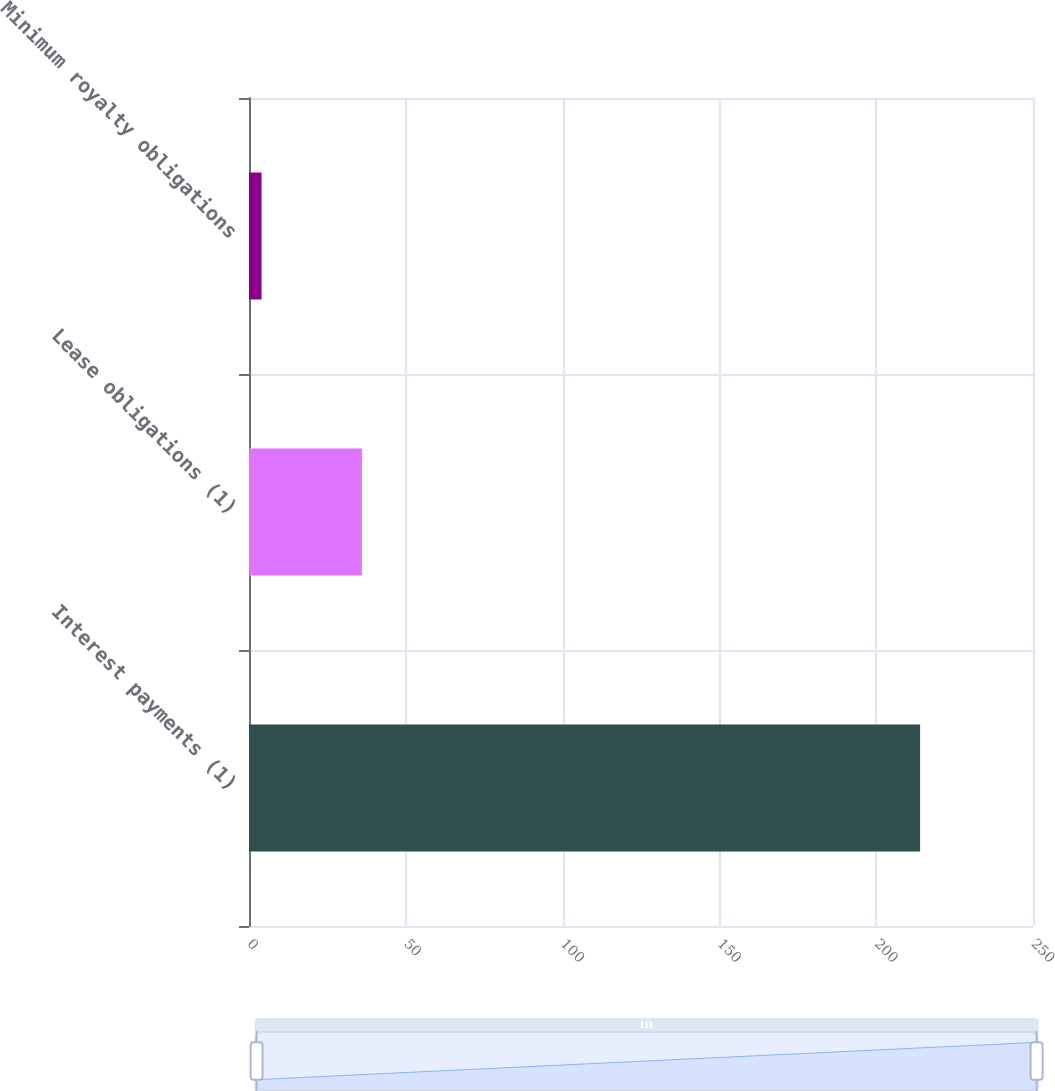<chart> <loc_0><loc_0><loc_500><loc_500><bar_chart><fcel>Interest payments (1)<fcel>Lease obligations (1)<fcel>Minimum royalty obligations<nl><fcel>214<fcel>36<fcel>4<nl></chart> 